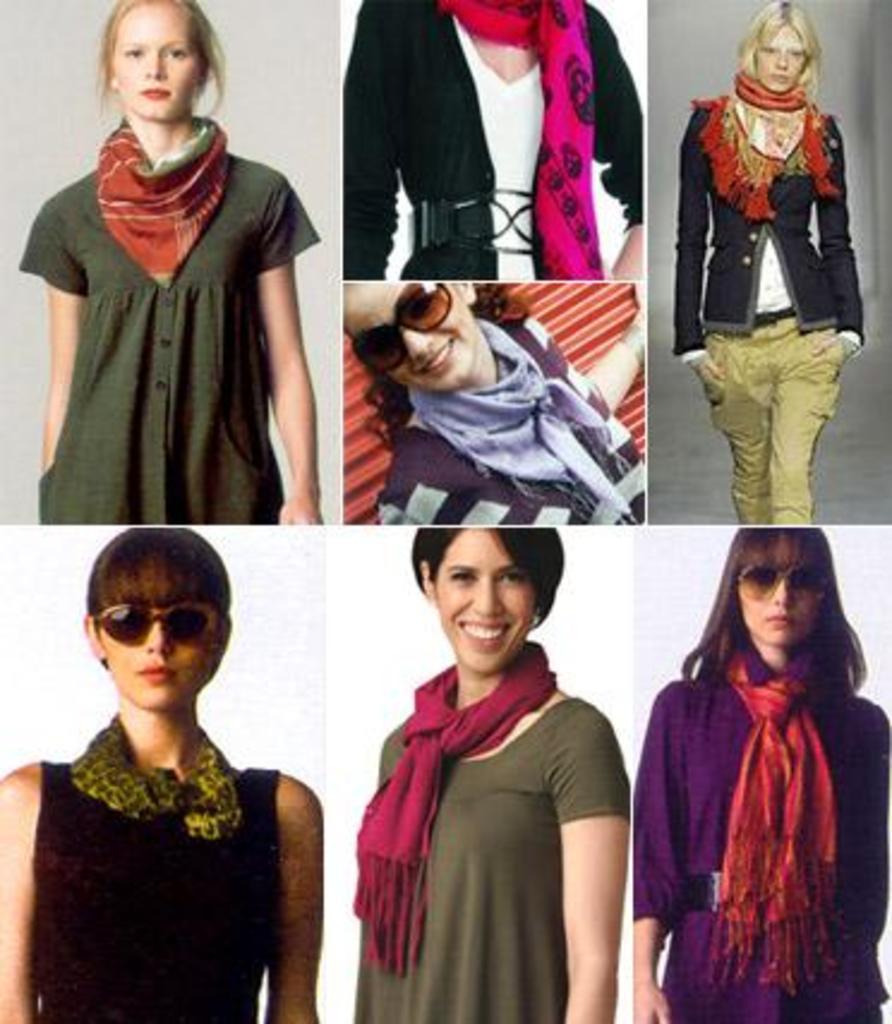Can you describe this image briefly? In this image I can see collage photos of women and I can see most of them are wearing scarves and shades. I can also see smile on few faces. 